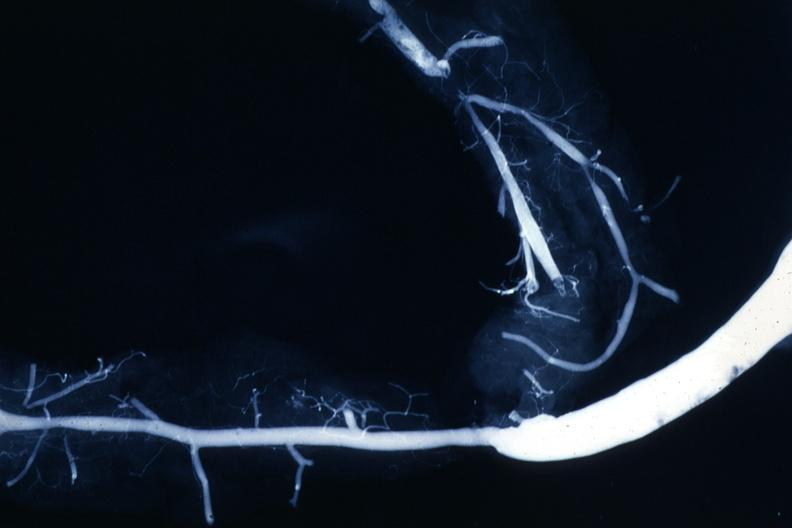s cardiovascular present?
Answer the question using a single word or phrase. Yes 